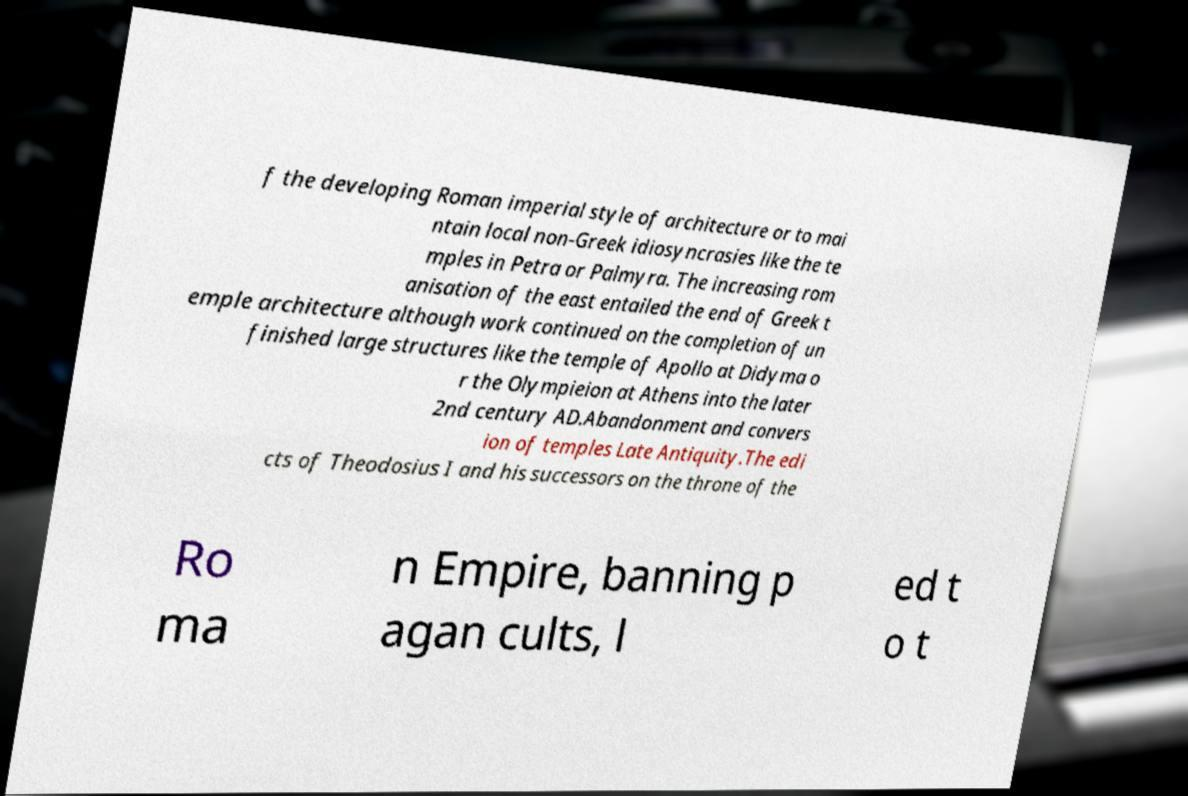There's text embedded in this image that I need extracted. Can you transcribe it verbatim? f the developing Roman imperial style of architecture or to mai ntain local non-Greek idiosyncrasies like the te mples in Petra or Palmyra. The increasing rom anisation of the east entailed the end of Greek t emple architecture although work continued on the completion of un finished large structures like the temple of Apollo at Didyma o r the Olympieion at Athens into the later 2nd century AD.Abandonment and convers ion of temples Late Antiquity.The edi cts of Theodosius I and his successors on the throne of the Ro ma n Empire, banning p agan cults, l ed t o t 